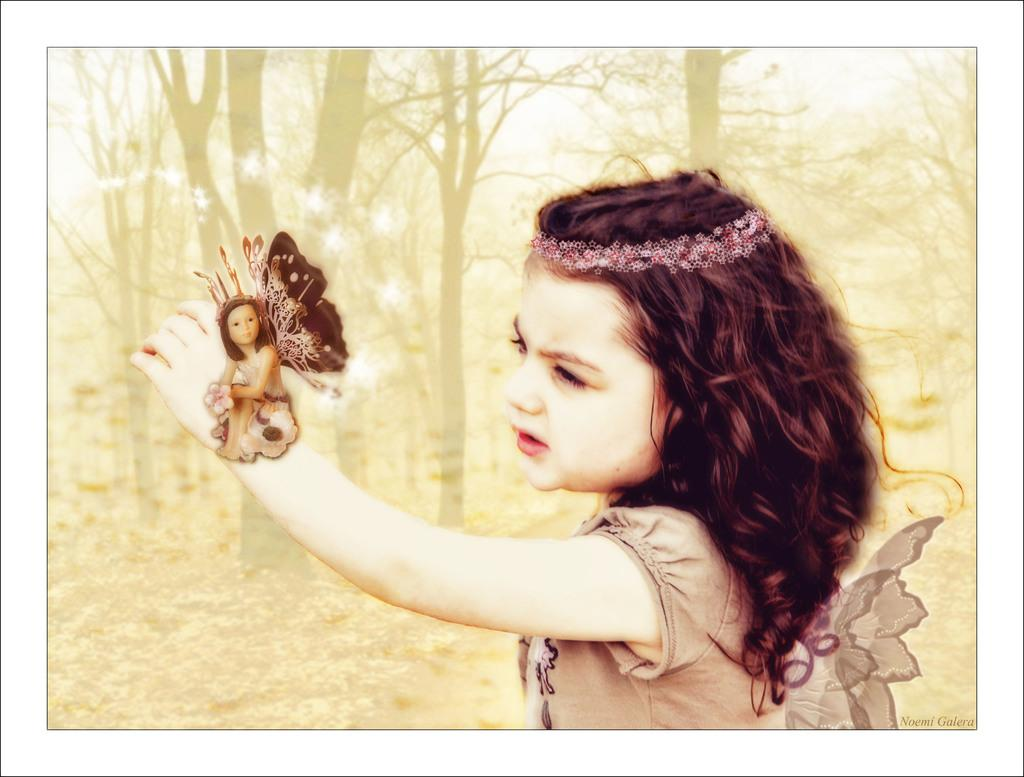Who is the main subject in the image? There is a girl in the image. Where is the girl located in the image? The girl is in the middle of the image. What can be seen in the middle of the image besides the girl? There are trees in the middle of the image. What is the girl holding in her hand? The girl is holding something in her hand, but we cannot determine what it is from the image. What accessory is the girl wearing? The girl is wearing a hairband. How much does the girl weigh in the image? We cannot determine the girl's weight from the image. What type of pickle is on the girl's knee in the image? There is no pickle present on the girl's knee in the image. 